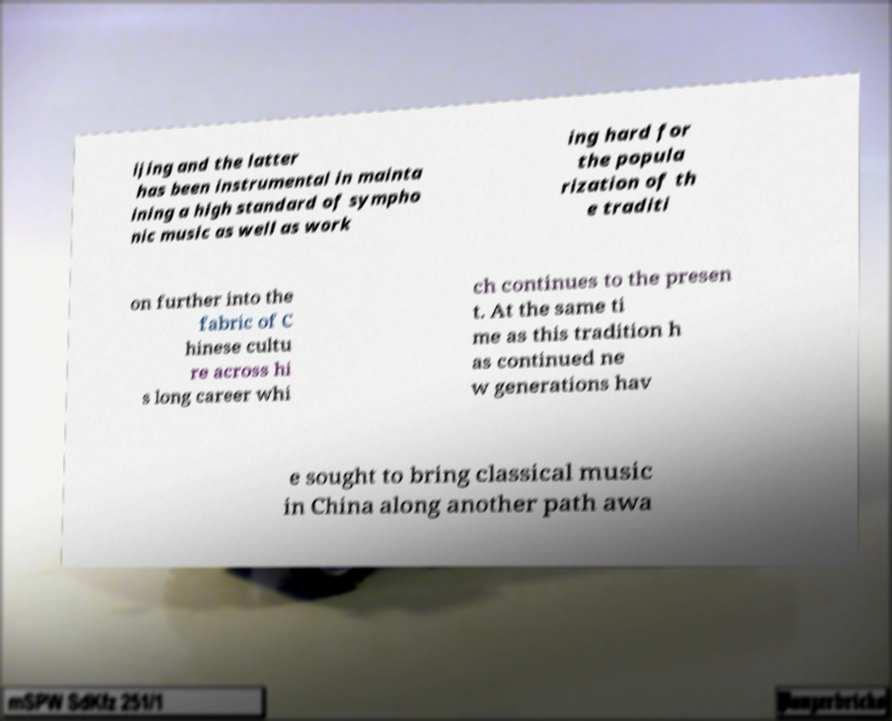There's text embedded in this image that I need extracted. Can you transcribe it verbatim? ijing and the latter has been instrumental in mainta ining a high standard of sympho nic music as well as work ing hard for the popula rization of th e traditi on further into the fabric of C hinese cultu re across hi s long career whi ch continues to the presen t. At the same ti me as this tradition h as continued ne w generations hav e sought to bring classical music in China along another path awa 